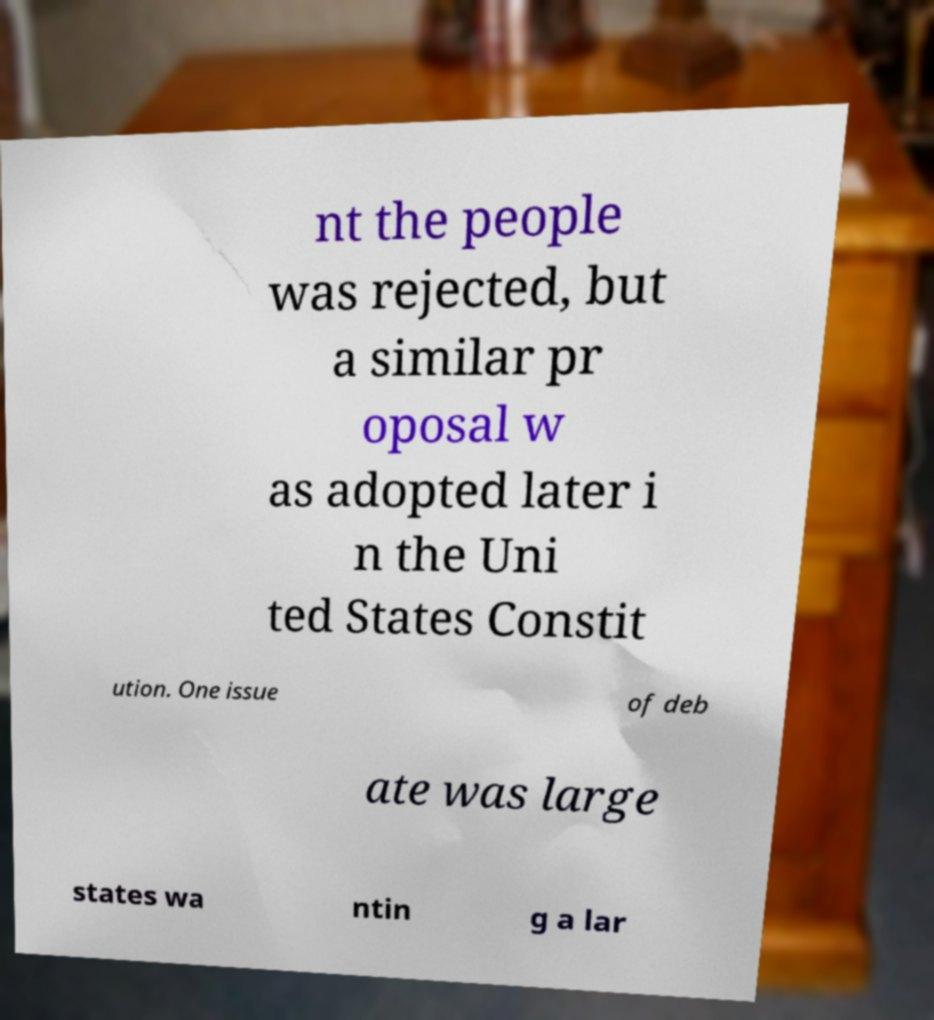Please read and relay the text visible in this image. What does it say? nt the people was rejected, but a similar pr oposal w as adopted later i n the Uni ted States Constit ution. One issue of deb ate was large states wa ntin g a lar 